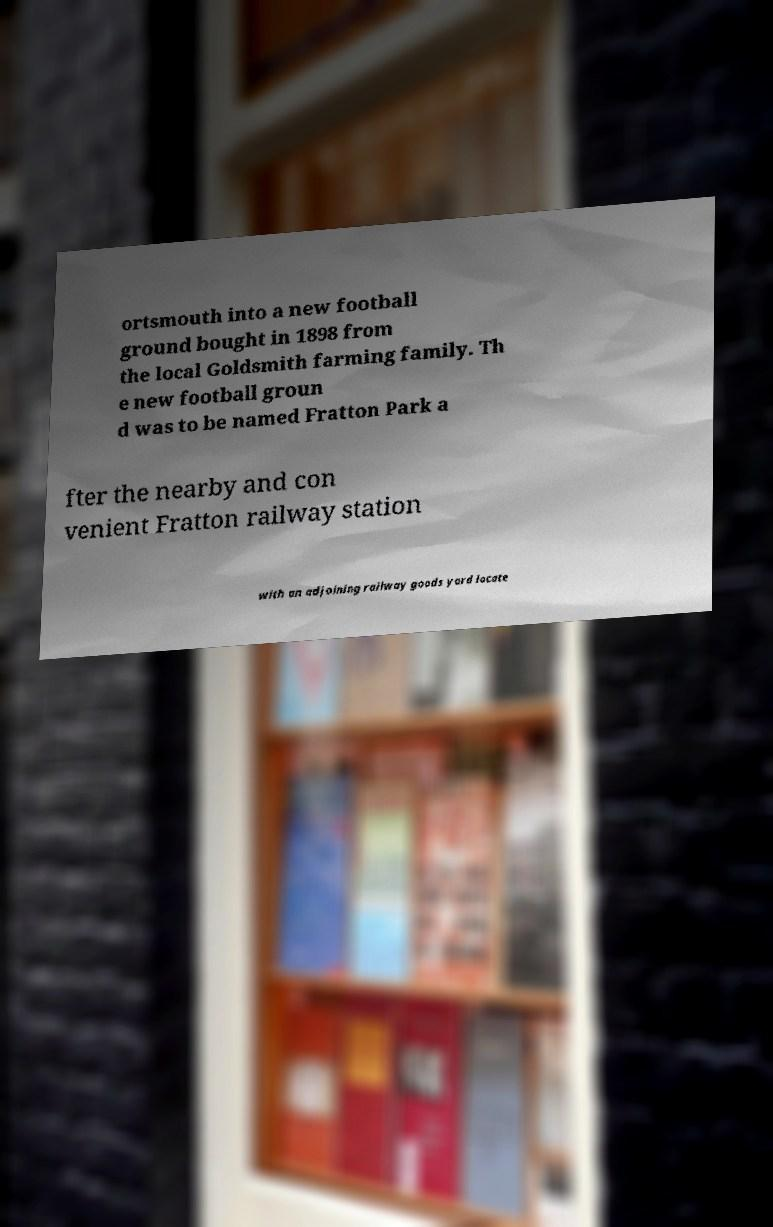There's text embedded in this image that I need extracted. Can you transcribe it verbatim? ortsmouth into a new football ground bought in 1898 from the local Goldsmith farming family. Th e new football groun d was to be named Fratton Park a fter the nearby and con venient Fratton railway station with an adjoining railway goods yard locate 